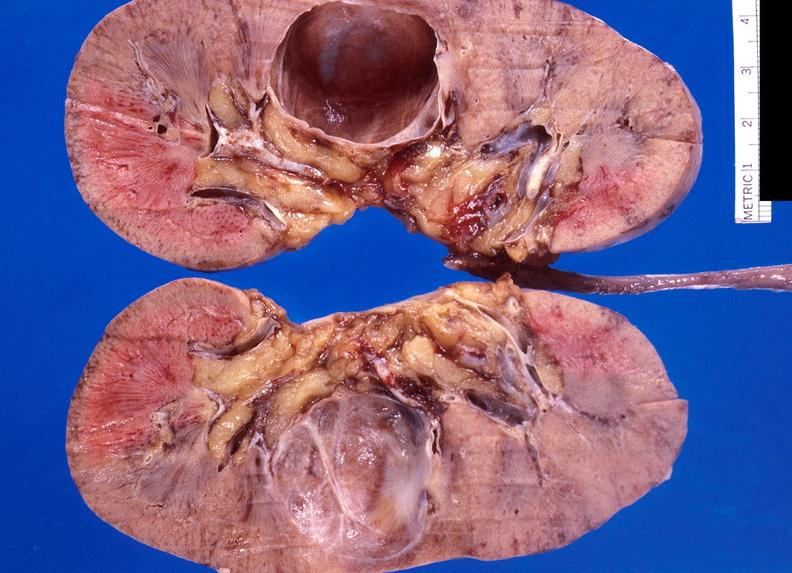what does this image show?
Answer the question using a single word or phrase. Renal cyst 